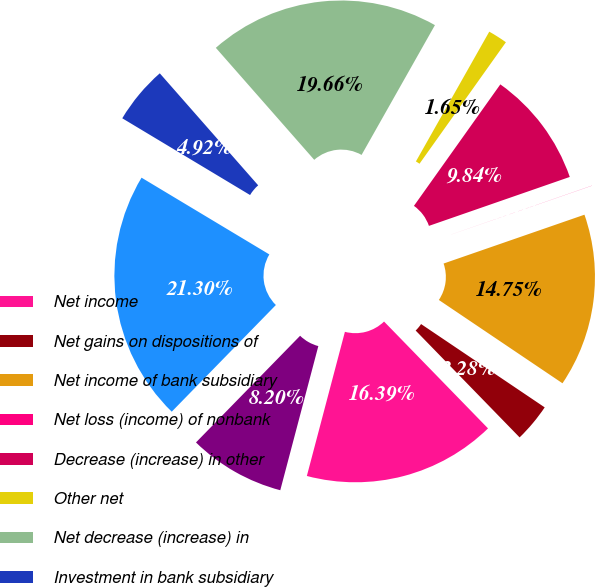Convert chart. <chart><loc_0><loc_0><loc_500><loc_500><pie_chart><fcel>Net income<fcel>Net gains on dispositions of<fcel>Net income of bank subsidiary<fcel>Net loss (income) of nonbank<fcel>Decrease (increase) in other<fcel>Other net<fcel>Net decrease (increase) in<fcel>Investment in bank subsidiary<fcel>Investment in nonbank<fcel>Net cash used by investing<nl><fcel>16.39%<fcel>3.28%<fcel>14.75%<fcel>0.01%<fcel>9.84%<fcel>1.65%<fcel>19.66%<fcel>4.92%<fcel>21.3%<fcel>8.2%<nl></chart> 